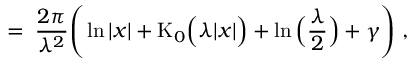Convert formula to latex. <formula><loc_0><loc_0><loc_500><loc_500>= \, \frac { 2 \pi } { \lambda ^ { 2 } } \left ( \ln | x | + K _ { 0 } \left ( \lambda | x | \right ) + \ln \left ( \frac { \lambda } { 2 } \right ) + \gamma \right ) \, ,</formula> 